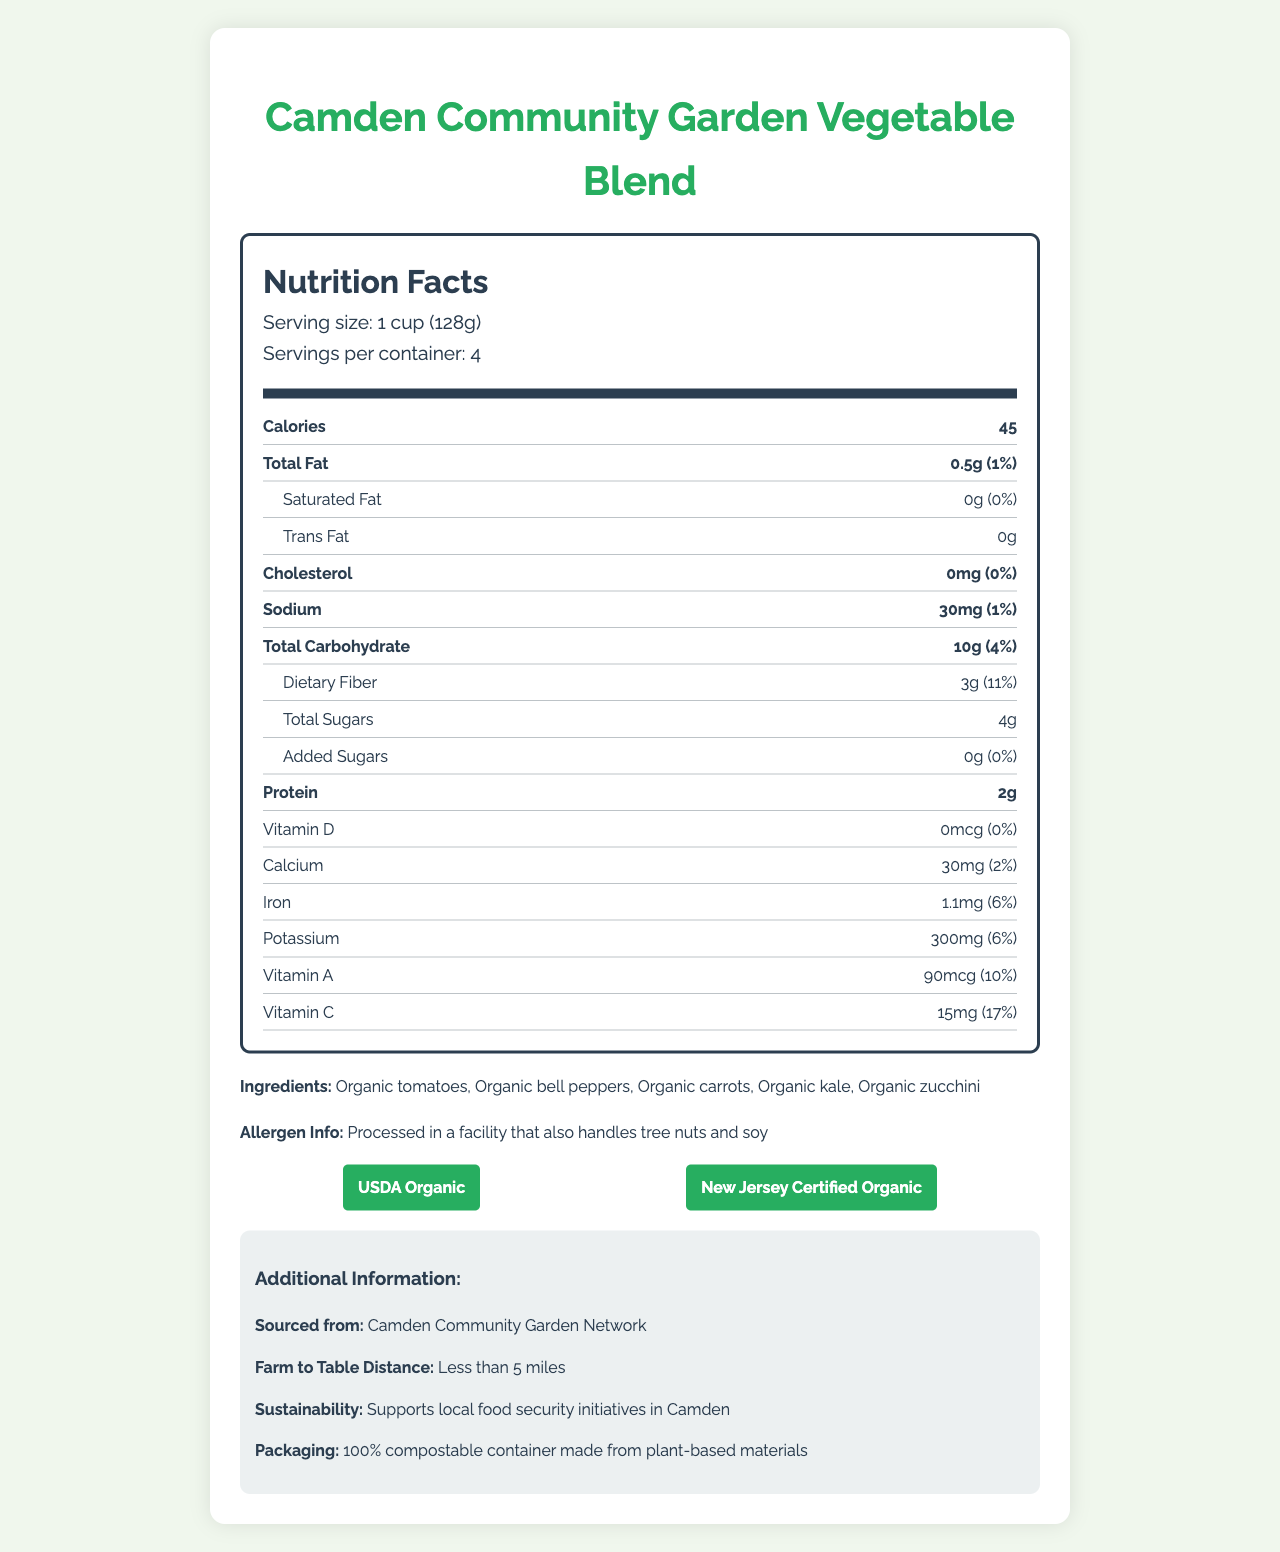what is the serving size for the Camden Community Garden Vegetable Blend? The document lists the serving size as "1 cup (128g)" in the nutrition facts section.
Answer: 1 cup (128g) how many servings are there per container? The document states "Servings per container: 4" in the nutrition facts section.
Answer: 4 what amount of dietary fiber is in one serving? Under the nutritional information, the dietary fiber content is listed as "3g".
Answer: 3g how much sodium does one serving contain? The nutritional information section of the document shows that one serving contains "30mg" of sodium.
Answer: 30mg what is the daily value percentage for vitamin C? The document states that the daily value percentage for vitamin C is "17%" in the nutrition facts section.
Answer: 17% which of the following is not an ingredient in the Camden Community Garden Vegetable Blend? A. Organic tomatoes B. Organic bell peppers C. Organic spinach D. Organic kale The listed ingredients are organic tomatoes, organic bell peppers, organic carrots, organic kale, and organic zucchini. Organic spinach is not listed.
Answer: C what certifications does the product have? A. USDA Organic B. Fair Trade Certified C. New Jersey Certified Organic D. GMO-Free The document includes certifications for "USDA Organic" and "New Jersey Certified Organic".
Answer: A. USDA Organic and C. New Jersey Certified Organic is the facility that processes the product also handling tree nuts and soy? The allergen information section notes that the product is processed in a facility that also handles tree nuts and soy.
Answer: Yes does the product support local food security initiatives in Camden? The additional information section states that the product "Supports local food security initiatives in Camden".
Answer: Yes summarize the main details provided in the document. The document thoroughly describes various details such as nutrient facts, ingredient list, allergen information, sourcing details, sustainability efforts, and certifications.
Answer: The Camden Community Garden Vegetable Blend is an organic, locally-sourced vegetable mix. Each container has 4 servings, with each serving being 1 cup (128g). The blend has low calories, low fat, and good amounts of dietary fiber. It's certified USDA Organic and New Jersey Certified Organic, processed in a facility handling tree nuts and soy, and supports local food security initiatives. The packaging is compostable, and the product is sourced from within 5 miles of Camden. how far is the farm from the table for this product? The additional information section states "Farm to table distance: Less than 5 miles".
Answer: Less than 5 miles is the amount of protein in the product sufficient to meet 10% of the daily value? The document lists the amount of protein per serving as "2g" but does not provide the USDA daily value percentage, so its sufficiency cannot be determined from the given information.
Answer: Cannot be determined 